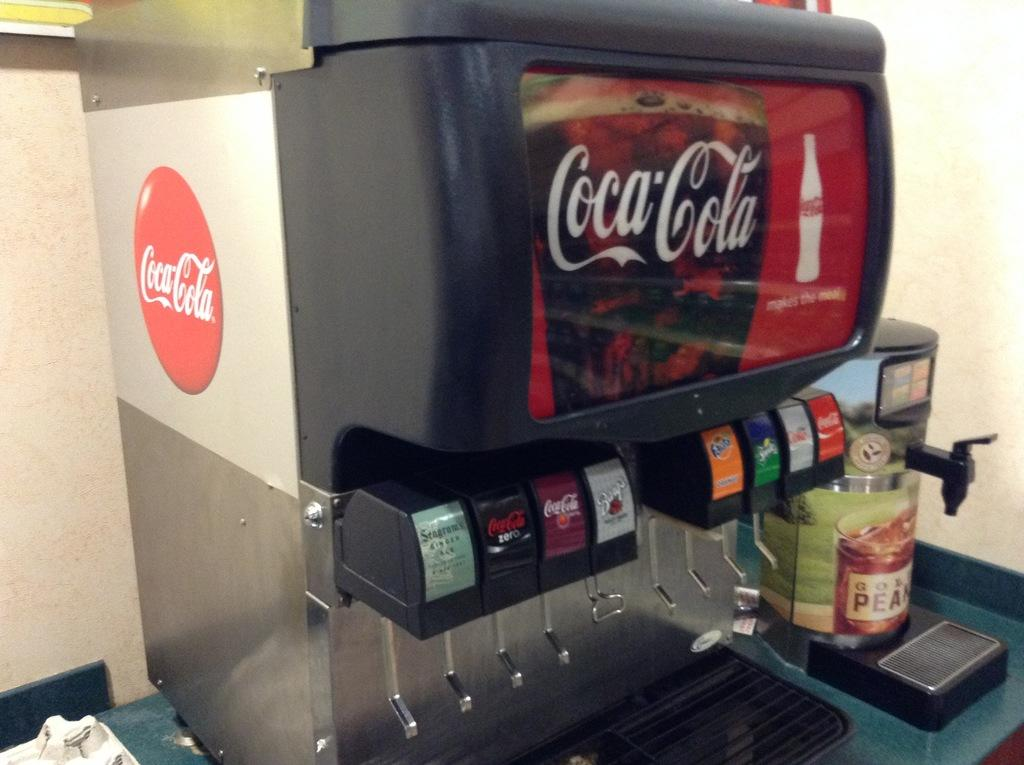<image>
Describe the image concisely. a coca cola machine has cherry coke too 